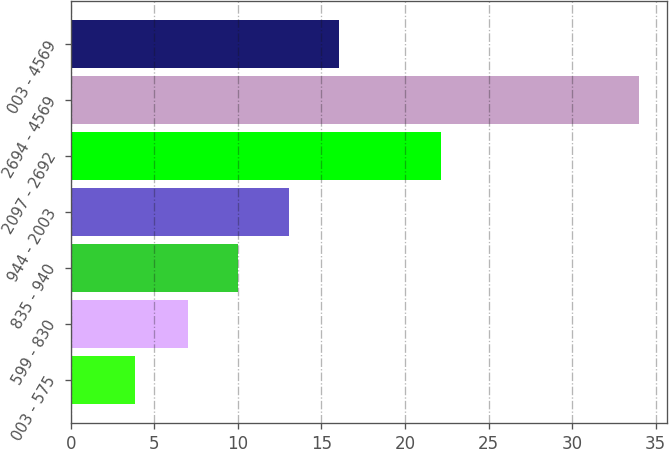<chart> <loc_0><loc_0><loc_500><loc_500><bar_chart><fcel>003 - 575<fcel>599 - 830<fcel>835 - 940<fcel>944 - 2003<fcel>2097 - 2692<fcel>2694 - 4569<fcel>003 - 4569<nl><fcel>3.85<fcel>7<fcel>10.02<fcel>13.04<fcel>22.18<fcel>34<fcel>16.05<nl></chart> 